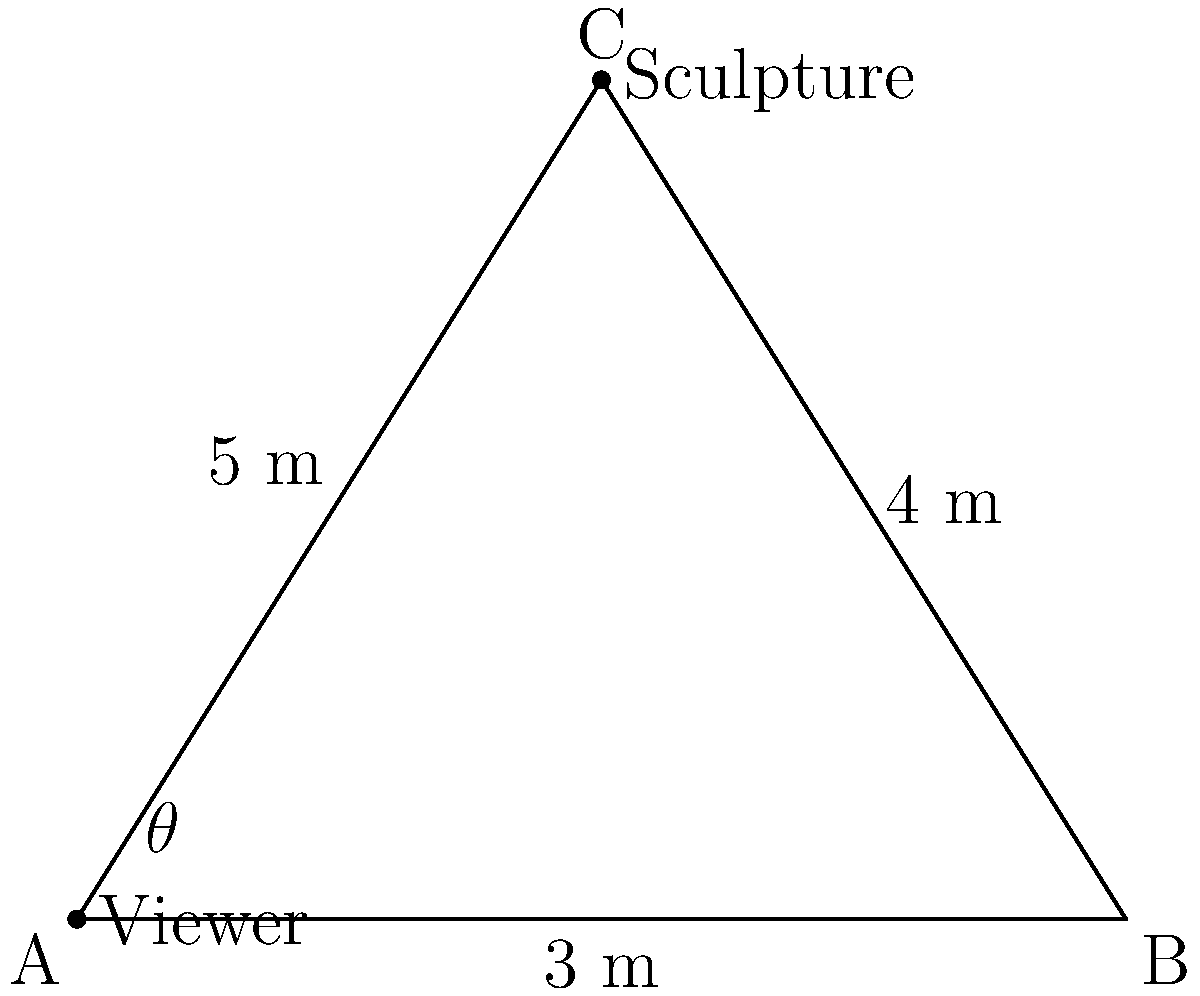In a minimalist exhibition space, you're positioning a wall-mounted sculpture for optimal viewing. The sculpture is placed 3 meters from the left wall and 4 meters above eye level. If you stand 5 meters away from the wall, what is the optimal viewing angle $\theta$ (in degrees) to look up at the sculpture? To solve this problem, we'll use trigonometry in the right-angled triangle formed by the viewer, the sculpture, and the point directly below the sculpture on the floor.

1. Identify the triangle sides:
   - Adjacent side (a) = 3 m (distance from left wall to viewer)
   - Opposite side (o) = 4 m (height of sculpture above eye level)
   - Hypotenuse (h) = 5 m (distance from viewer to sculpture)

2. We need to find the angle $\theta$. Since we know the opposite and adjacent sides, we can use the arctangent function:

   $$\theta = \arctan(\frac{\text{opposite}}{\text{adjacent}})$$

3. Substitute the values:
   $$\theta = \arctan(\frac{4}{3})$$

4. Calculate:
   $$\theta \approx 53.13^\circ$$

5. Round to the nearest degree:
   $$\theta \approx 53^\circ$$

Thus, the optimal viewing angle is approximately 53 degrees.
Answer: $53^\circ$ 